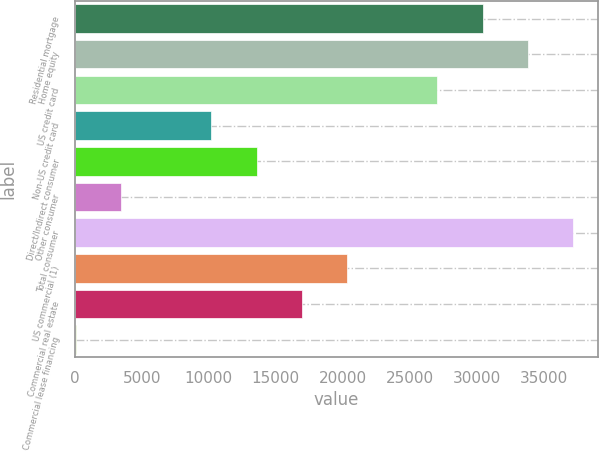Convert chart. <chart><loc_0><loc_0><loc_500><loc_500><bar_chart><fcel>Residential mortgage<fcel>Home equity<fcel>US credit card<fcel>Non-US credit card<fcel>Direct/Indirect consumer<fcel>Other consumer<fcel>Total consumer<fcel>US commercial (1)<fcel>Commercial real estate<fcel>Commercial lease financing<nl><fcel>30413.9<fcel>33783<fcel>27044.8<fcel>10199.3<fcel>13568.4<fcel>3461.1<fcel>37152.1<fcel>20306.6<fcel>16937.5<fcel>92<nl></chart> 